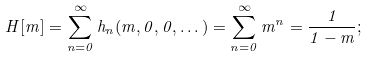Convert formula to latex. <formula><loc_0><loc_0><loc_500><loc_500>H [ m ] = \sum _ { n = 0 } ^ { \infty } h _ { n } ( m , 0 , 0 , \dots ) = \sum _ { n = 0 } ^ { \infty } m ^ { n } = \frac { 1 } { 1 - m } ;</formula> 